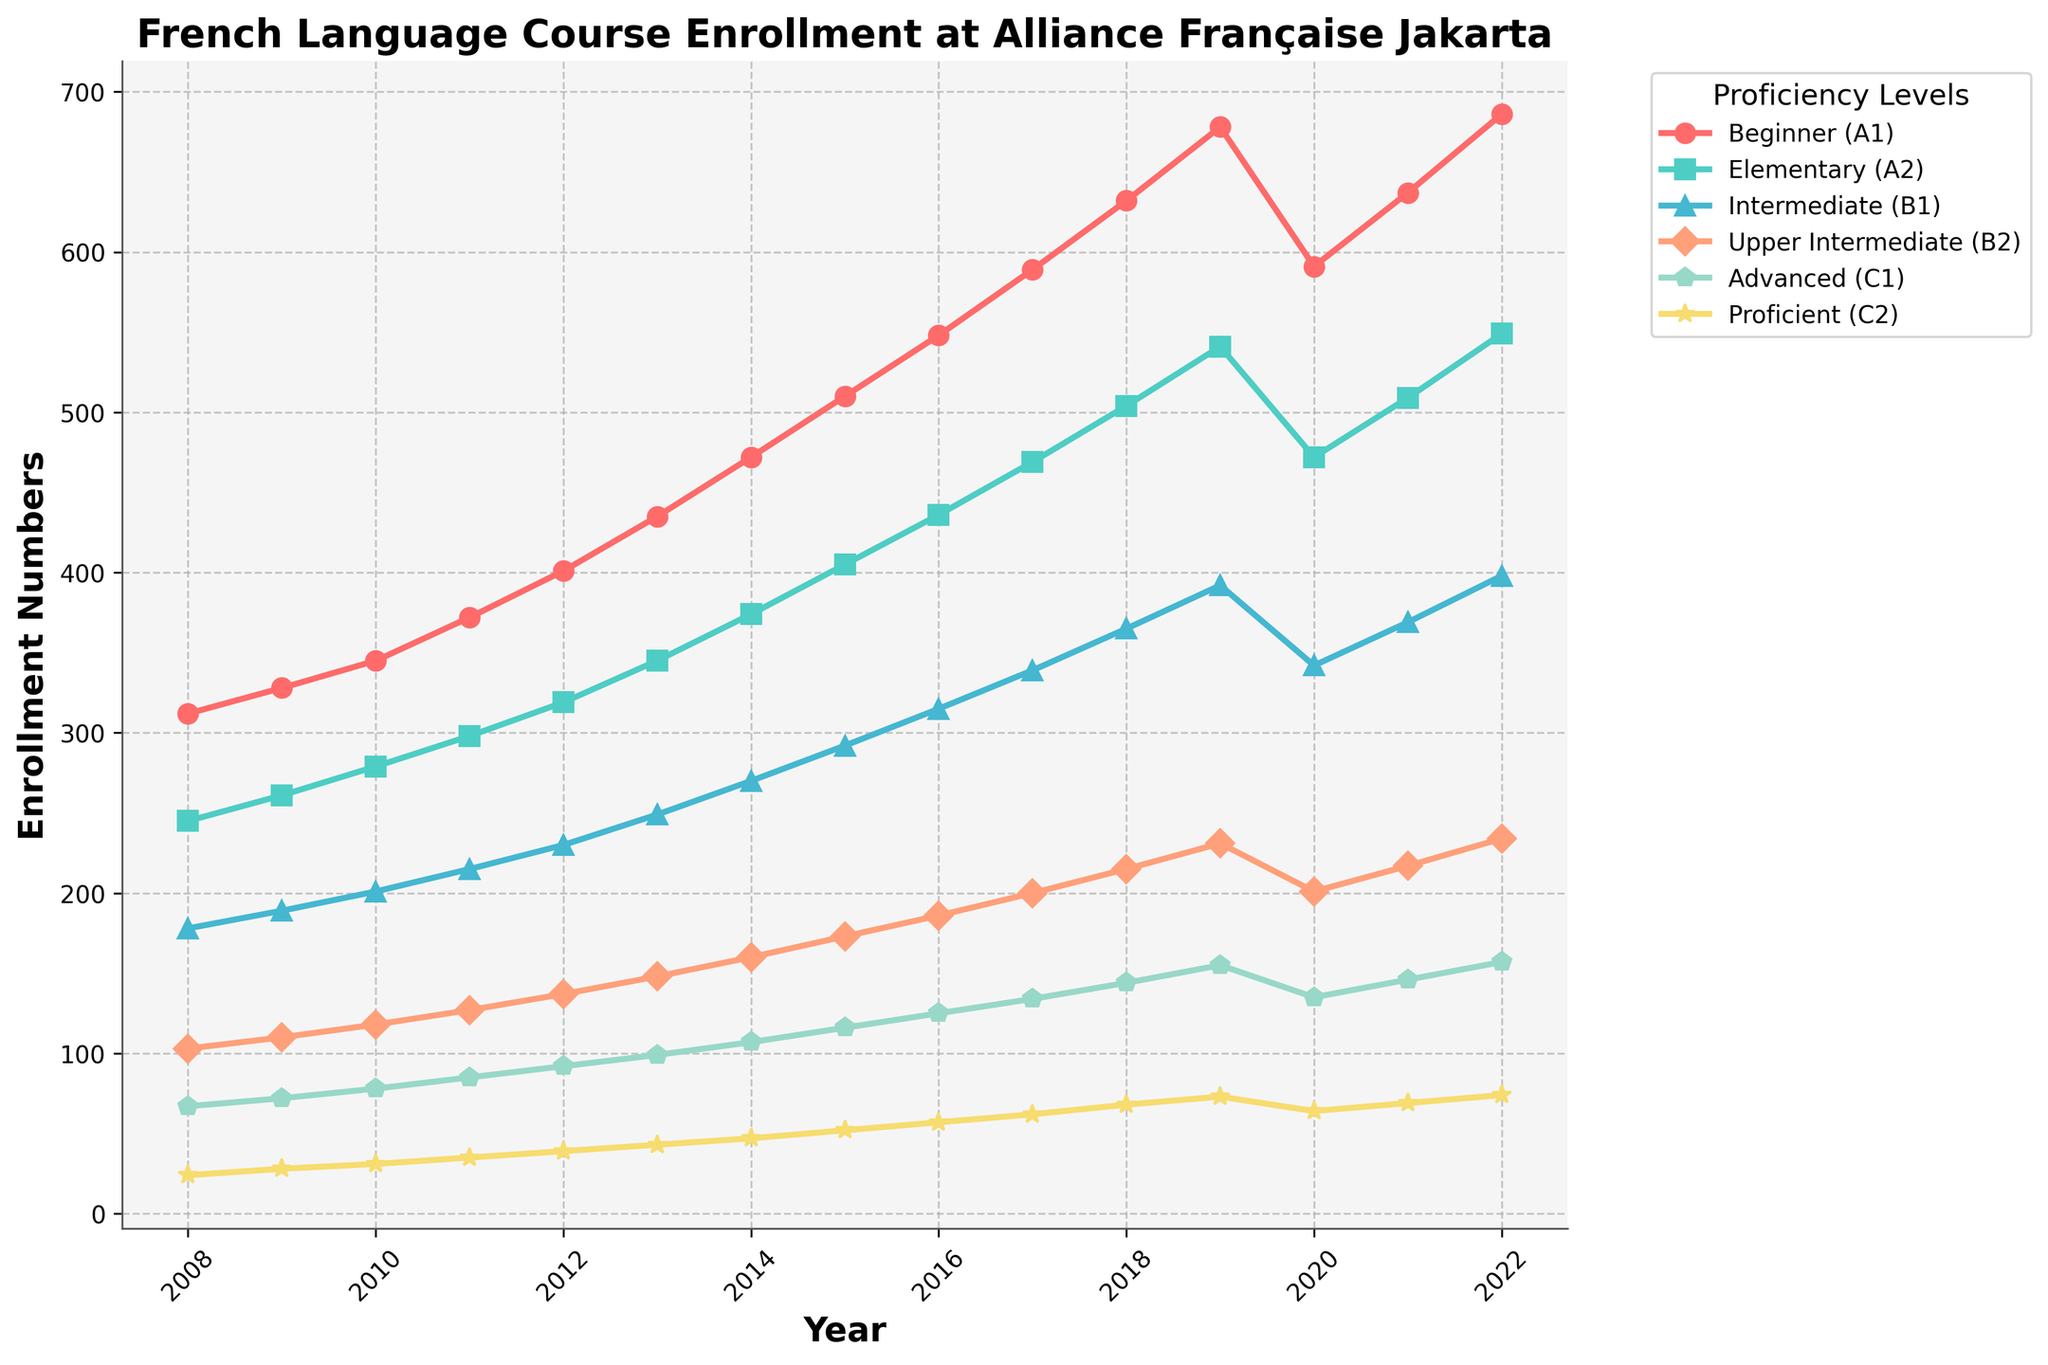What is the enrollment trend for the Beginner (A1) level from 2008 to 2022? The Beginner (A1) enrollment shows a steady increase from 312 in 2008 to 686 in 2022, with a minor drop in 2020. This indicates a growing interest overall in starting French courses.
Answer: Steadily increasing Which proficiency level had the highest enrollment in 2022? Looking at the plotted lines for 2022, the Beginner (A1) level had the highest enrollment with 686 students.
Answer: Beginner (A1) How did the enrollment numbers for the Intermediate (B1) level change between 2010 and 2015? Enrollment for Intermediate (B1) in 2010 was 201. It then increased annually, reaching 292 in 2015.
Answer: Increased from 201 to 292 Which proficiency level saw the biggest drop in enrollment numbers in 2020 compared to 2019? By comparing the lines for each proficiency level, Beginner (A1) shows the biggest drop, decreasing from 678 in 2019 to 591 in 2020.
Answer: Beginner (A1) What is the average enrollment for the Advanced (C1) level over the entire period? Summing the Advanced (C1) enrollments from 2008 to 2022 and dividing by the number of years: (67+72+78+85+92+99+107+116+125+134+144+155+135+146+157)/15 = 110.73.
Answer: 110.73 Between which years did the Upper Intermediate (B2) level see the most significant growth? The most significant growth can be seen between 2017 and 2018 where the enrollment numbers increased from 200 to 215.
Answer: 2017 to 2018 Compare the enrollment numbers for Proficient (C2) and Beginner (A1) in 2014. What is the difference in their enrollments? Enrollment for Beginner (A1) in 2014 was 472, and Proficient (C2) was 47. The difference is 472 - 47 = 425.
Answer: 425 How did the enrollment for Elementary (A2) change from 2008 to 2022? The enrollment for Elementary (A2) increased from 245 in 2008 to 549 in 2022, indicating continuous growth over the years.
Answer: Increased from 245 to 549 Which proficiency level consistently had the lowest enrollment number over the 15-year period, and what was its enrollment in 2022? The Proficient (C2) level consistently had the lowest enrollment numbers, having 74 enrollments in 2022.
Answer: Proficient (C2) with 74 In which year did Beginner (A1) surpass 500 enrollments? Beginner (A1) surpassed 500 enrollments in 2015, as seen from the chart.
Answer: 2015 